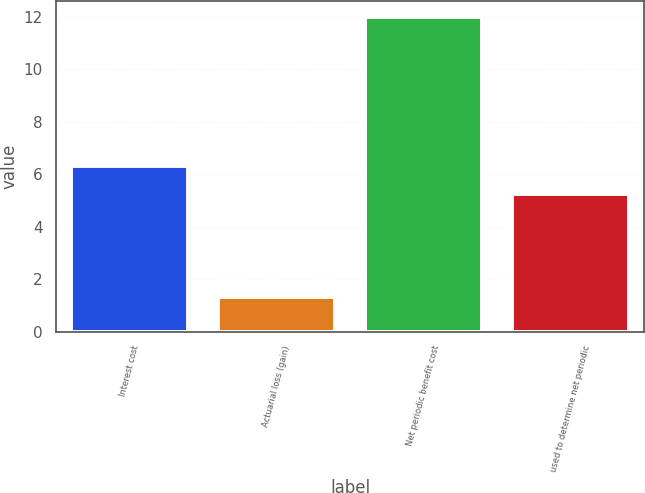<chart> <loc_0><loc_0><loc_500><loc_500><bar_chart><fcel>Interest cost<fcel>Actuarial loss (gain)<fcel>Net periodic benefit cost<fcel>used to determine net periodic<nl><fcel>6.32<fcel>1.3<fcel>12<fcel>5.25<nl></chart> 